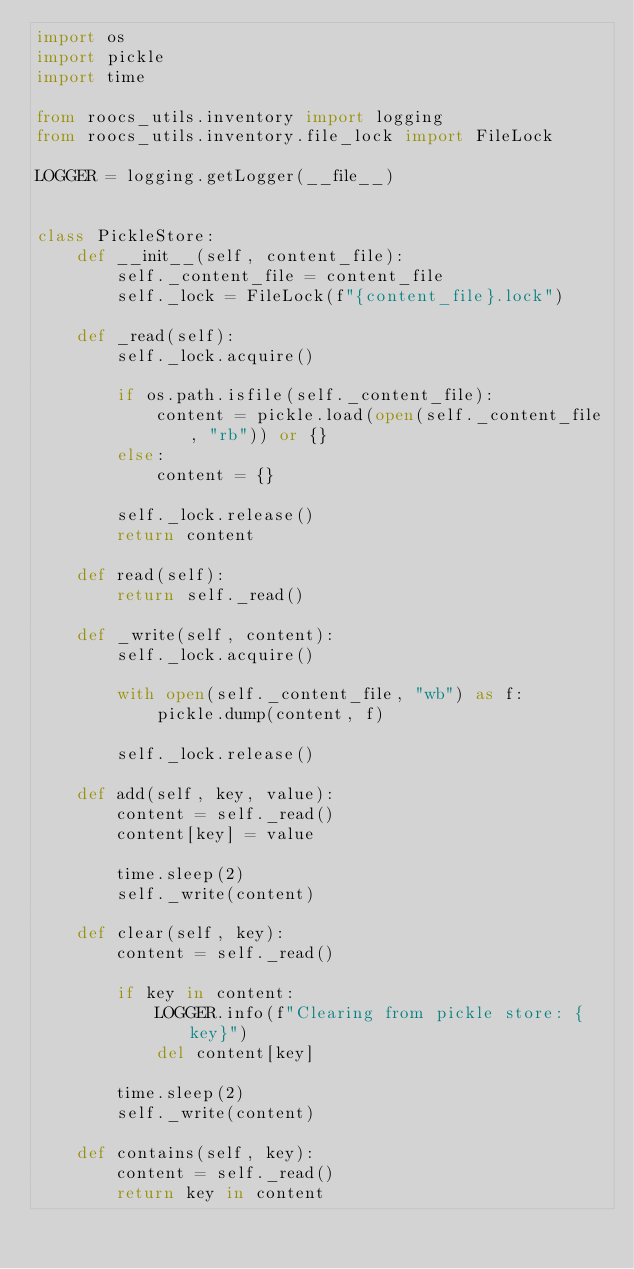Convert code to text. <code><loc_0><loc_0><loc_500><loc_500><_Python_>import os
import pickle
import time

from roocs_utils.inventory import logging
from roocs_utils.inventory.file_lock import FileLock

LOGGER = logging.getLogger(__file__)


class PickleStore:
    def __init__(self, content_file):
        self._content_file = content_file
        self._lock = FileLock(f"{content_file}.lock")

    def _read(self):
        self._lock.acquire()

        if os.path.isfile(self._content_file):
            content = pickle.load(open(self._content_file, "rb")) or {}
        else:
            content = {}

        self._lock.release()
        return content

    def read(self):
        return self._read()

    def _write(self, content):
        self._lock.acquire()

        with open(self._content_file, "wb") as f:
            pickle.dump(content, f)

        self._lock.release()

    def add(self, key, value):
        content = self._read()
        content[key] = value

        time.sleep(2)
        self._write(content)

    def clear(self, key):
        content = self._read()

        if key in content:
            LOGGER.info(f"Clearing from pickle store: {key}")
            del content[key]

        time.sleep(2)
        self._write(content)

    def contains(self, key):
        content = self._read()
        return key in content
</code> 